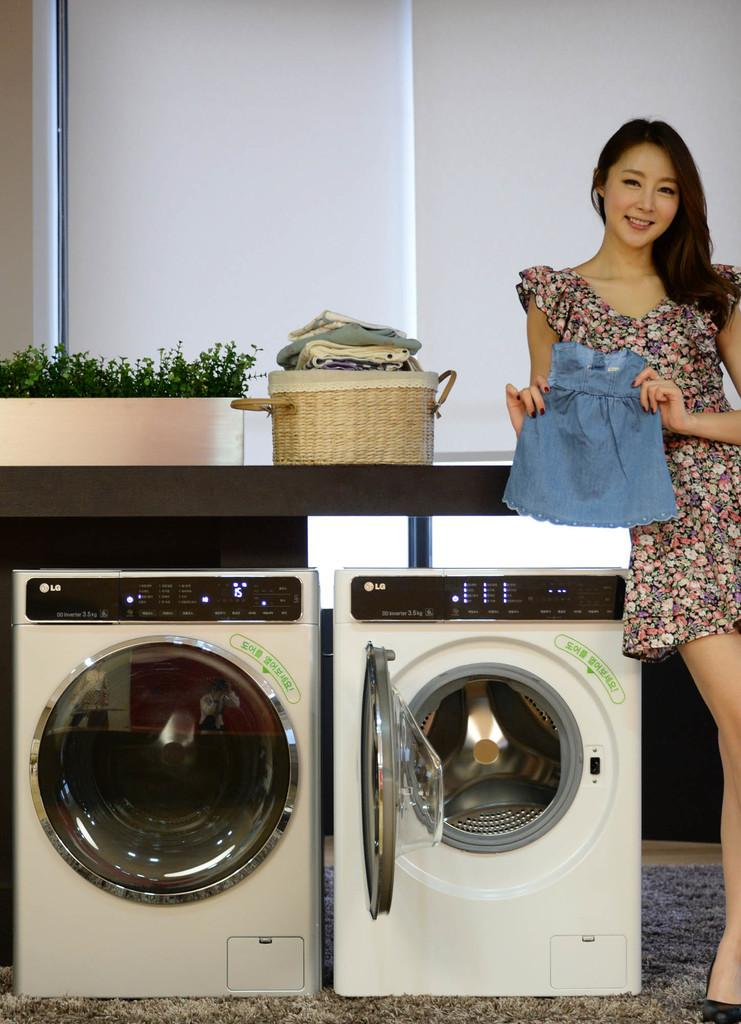<image>
Give a short and clear explanation of the subsequent image. A woman is posing next to 2 LG appliances. 